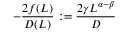<formula> <loc_0><loc_0><loc_500><loc_500>- \frac { 2 f ( L ) } { D ( L ) } \colon = \frac { 2 \gamma L ^ { \alpha - \beta } } { D }</formula> 